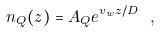Convert formula to latex. <formula><loc_0><loc_0><loc_500><loc_500>n _ { Q } ( z ) = A _ { Q } e ^ { v _ { w } z / D } \ ,</formula> 